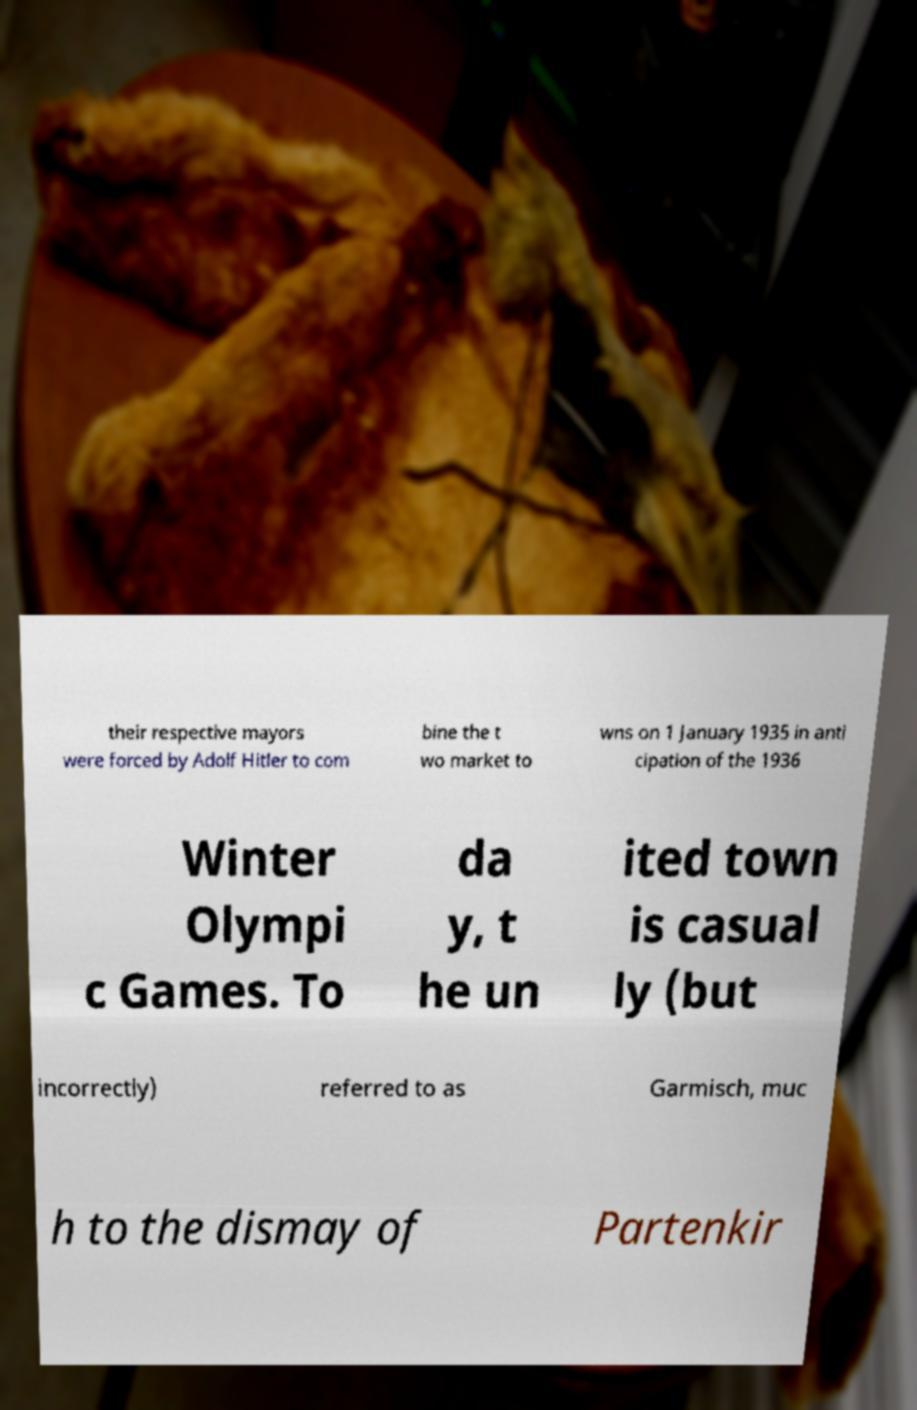Please read and relay the text visible in this image. What does it say? their respective mayors were forced by Adolf Hitler to com bine the t wo market to wns on 1 January 1935 in anti cipation of the 1936 Winter Olympi c Games. To da y, t he un ited town is casual ly (but incorrectly) referred to as Garmisch, muc h to the dismay of Partenkir 